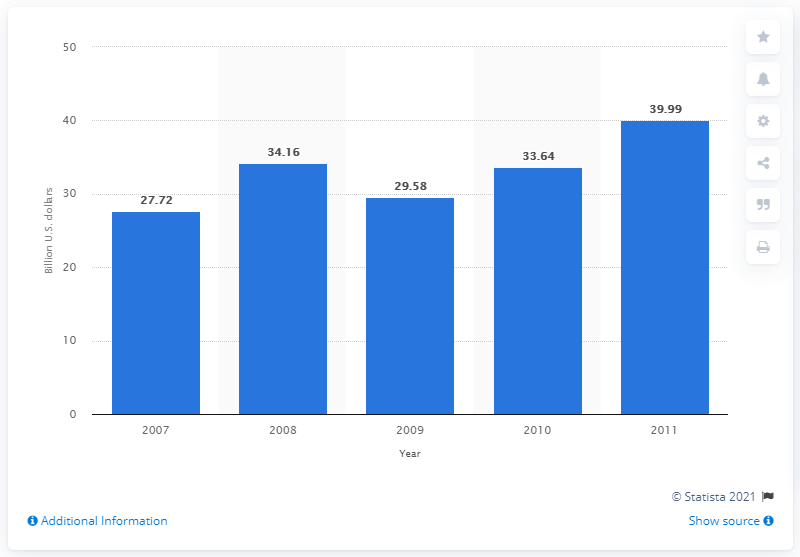Indicate a few pertinent items in this graphic. In 2008, the retail net sales in Kazakhstan totaled 34.16 dollars. 